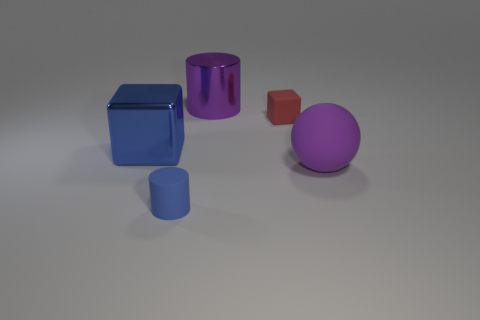Do the big metal object right of the tiny blue rubber cylinder and the tiny blue matte thing have the same shape?
Make the answer very short. Yes. There is a blue thing that is the same shape as the big purple metallic thing; what is it made of?
Make the answer very short. Rubber. There is a small red rubber thing; does it have the same shape as the shiny thing that is to the left of the small rubber cylinder?
Provide a succinct answer. Yes. There is a thing that is both to the right of the big metallic cylinder and on the left side of the large rubber object; what is its color?
Your answer should be compact. Red. Are any large green rubber spheres visible?
Make the answer very short. No. Are there the same number of purple cylinders to the right of the purple shiny thing and cylinders?
Your answer should be compact. No. How many other things are there of the same shape as the purple rubber object?
Give a very brief answer. 0. What is the shape of the purple rubber object?
Offer a very short reply. Sphere. Does the tiny blue cylinder have the same material as the large cube?
Give a very brief answer. No. Are there the same number of metallic cylinders on the right side of the small red rubber block and tiny matte things that are in front of the big purple ball?
Provide a short and direct response. No. 